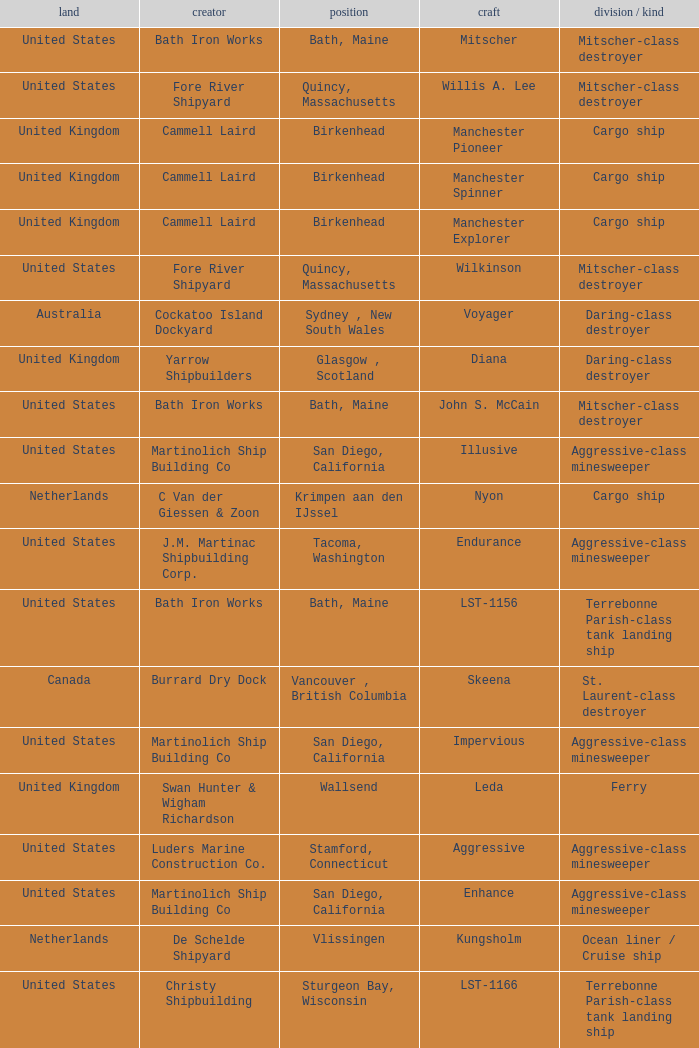Give me the full table as a dictionary. {'header': ['land', 'creator', 'position', 'craft', 'division / kind'], 'rows': [['United States', 'Bath Iron Works', 'Bath, Maine', 'Mitscher', 'Mitscher-class destroyer'], ['United States', 'Fore River Shipyard', 'Quincy, Massachusetts', 'Willis A. Lee', 'Mitscher-class destroyer'], ['United Kingdom', 'Cammell Laird', 'Birkenhead', 'Manchester Pioneer', 'Cargo ship'], ['United Kingdom', 'Cammell Laird', 'Birkenhead', 'Manchester Spinner', 'Cargo ship'], ['United Kingdom', 'Cammell Laird', 'Birkenhead', 'Manchester Explorer', 'Cargo ship'], ['United States', 'Fore River Shipyard', 'Quincy, Massachusetts', 'Wilkinson', 'Mitscher-class destroyer'], ['Australia', 'Cockatoo Island Dockyard', 'Sydney , New South Wales', 'Voyager', 'Daring-class destroyer'], ['United Kingdom', 'Yarrow Shipbuilders', 'Glasgow , Scotland', 'Diana', 'Daring-class destroyer'], ['United States', 'Bath Iron Works', 'Bath, Maine', 'John S. McCain', 'Mitscher-class destroyer'], ['United States', 'Martinolich Ship Building Co', 'San Diego, California', 'Illusive', 'Aggressive-class minesweeper'], ['Netherlands', 'C Van der Giessen & Zoon', 'Krimpen aan den IJssel', 'Nyon', 'Cargo ship'], ['United States', 'J.M. Martinac Shipbuilding Corp.', 'Tacoma, Washington', 'Endurance', 'Aggressive-class minesweeper'], ['United States', 'Bath Iron Works', 'Bath, Maine', 'LST-1156', 'Terrebonne Parish-class tank landing ship'], ['Canada', 'Burrard Dry Dock', 'Vancouver , British Columbia', 'Skeena', 'St. Laurent-class destroyer'], ['United States', 'Martinolich Ship Building Co', 'San Diego, California', 'Impervious', 'Aggressive-class minesweeper'], ['United Kingdom', 'Swan Hunter & Wigham Richardson', 'Wallsend', 'Leda', 'Ferry'], ['United States', 'Luders Marine Construction Co.', 'Stamford, Connecticut', 'Aggressive', 'Aggressive-class minesweeper'], ['United States', 'Martinolich Ship Building Co', 'San Diego, California', 'Enhance', 'Aggressive-class minesweeper'], ['Netherlands', 'De Schelde Shipyard', 'Vlissingen', 'Kungsholm', 'Ocean liner / Cruise ship'], ['United States', 'Christy Shipbuilding', 'Sturgeon Bay, Wisconsin', 'LST-1166', 'Terrebonne Parish-class tank landing ship'], ['United States', 'Ingalls Shipbuilding', 'Pascagoula, Mississippi', 'LST-1161', 'Terrebonne Parish-class tank landing ship'], ['Finland', 'Wärtsilä Hietalahti shipyard', 'Helsinki', 'Voima', 'Icebreaker'], ['United States', 'Bath Iron Works', 'Bath, Maine', 'LST-1157', 'Terrebonne Parish-class tank landing ship'], ['United States', 'Fulton Shipyard', 'Antioch, California', 'Conflict', 'Aggressive-class minesweeper'], ['United States', 'Colberg Boat Works', 'Stockton, California', 'Dynamic', 'Aggressive-class minesweeper'], ['United States', 'Martinolich Ship Building Co', 'San Diego, California', 'Esteem', 'Aggressive-class minesweeper']]} What Country is the John S. McCain Ship from? United States. 